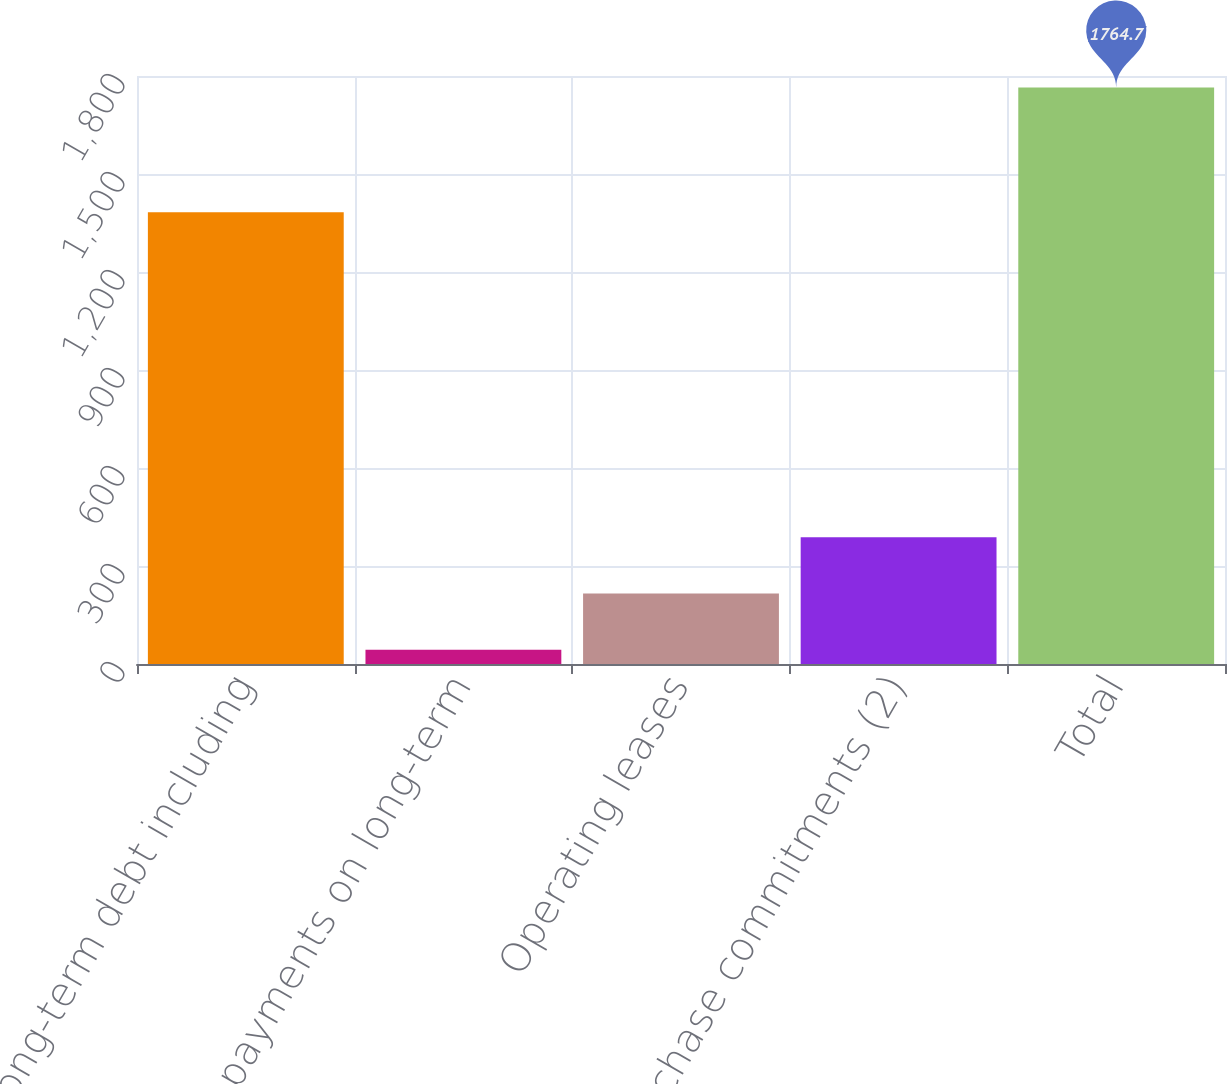Convert chart to OTSL. <chart><loc_0><loc_0><loc_500><loc_500><bar_chart><fcel>Long-term debt including<fcel>Interest payments on long-term<fcel>Operating leases<fcel>Purchase commitments (2)<fcel>Total<nl><fcel>1382.7<fcel>43.9<fcel>215.98<fcel>388.06<fcel>1764.7<nl></chart> 